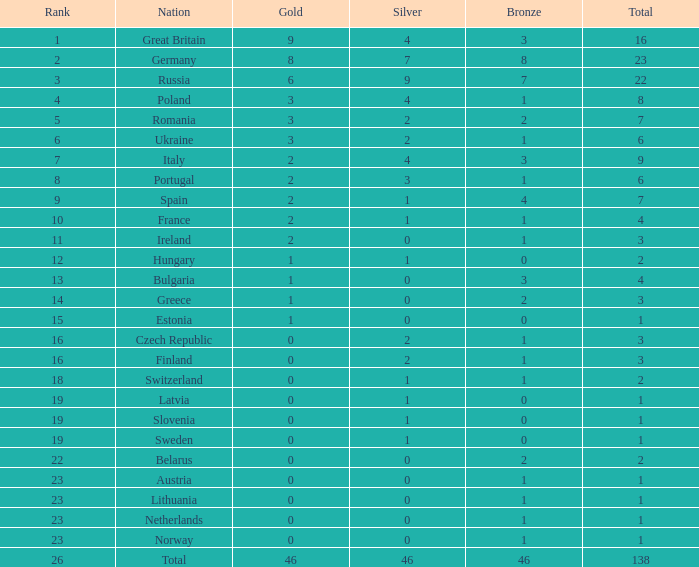When the total is larger than 1,and the bronze is less than 3, and silver larger than 2, and a gold larger than 2, what is the nation? Poland. 